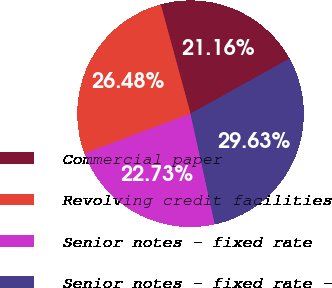Convert chart. <chart><loc_0><loc_0><loc_500><loc_500><pie_chart><fcel>Commercial paper<fcel>Revolving credit facilities<fcel>Senior notes - fixed rate<fcel>Senior notes - fixed rate -<nl><fcel>21.16%<fcel>26.48%<fcel>22.73%<fcel>29.63%<nl></chart> 